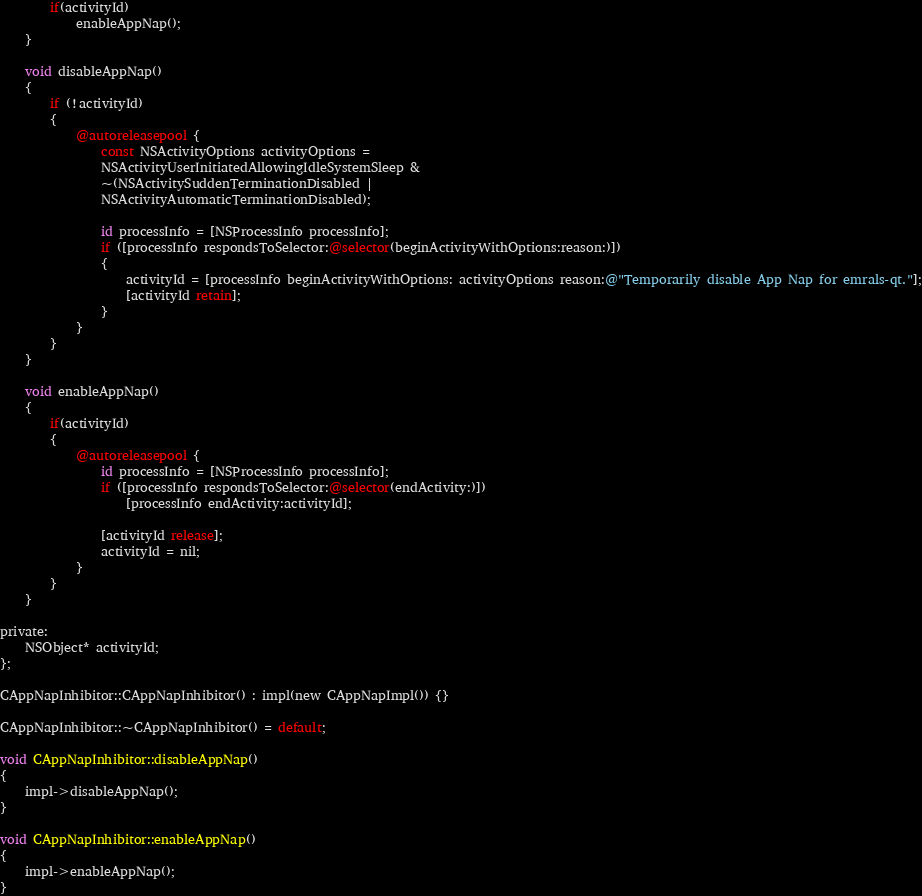<code> <loc_0><loc_0><loc_500><loc_500><_ObjectiveC_>        if(activityId)
            enableAppNap();
    }

    void disableAppNap()
    {
        if (!activityId)
        {
            @autoreleasepool {
                const NSActivityOptions activityOptions =
                NSActivityUserInitiatedAllowingIdleSystemSleep &
                ~(NSActivitySuddenTerminationDisabled |
                NSActivityAutomaticTerminationDisabled);

                id processInfo = [NSProcessInfo processInfo];
                if ([processInfo respondsToSelector:@selector(beginActivityWithOptions:reason:)])
                {
                    activityId = [processInfo beginActivityWithOptions: activityOptions reason:@"Temporarily disable App Nap for emrals-qt."];
                    [activityId retain];
                }
            }
        }
    }

    void enableAppNap()
    {
        if(activityId)
        {
            @autoreleasepool {
                id processInfo = [NSProcessInfo processInfo];
                if ([processInfo respondsToSelector:@selector(endActivity:)])
                    [processInfo endActivity:activityId];

                [activityId release];
                activityId = nil;
            }
        }
    }

private:
    NSObject* activityId;
};

CAppNapInhibitor::CAppNapInhibitor() : impl(new CAppNapImpl()) {}

CAppNapInhibitor::~CAppNapInhibitor() = default;

void CAppNapInhibitor::disableAppNap()
{
    impl->disableAppNap();
}

void CAppNapInhibitor::enableAppNap()
{
    impl->enableAppNap();
}
</code> 